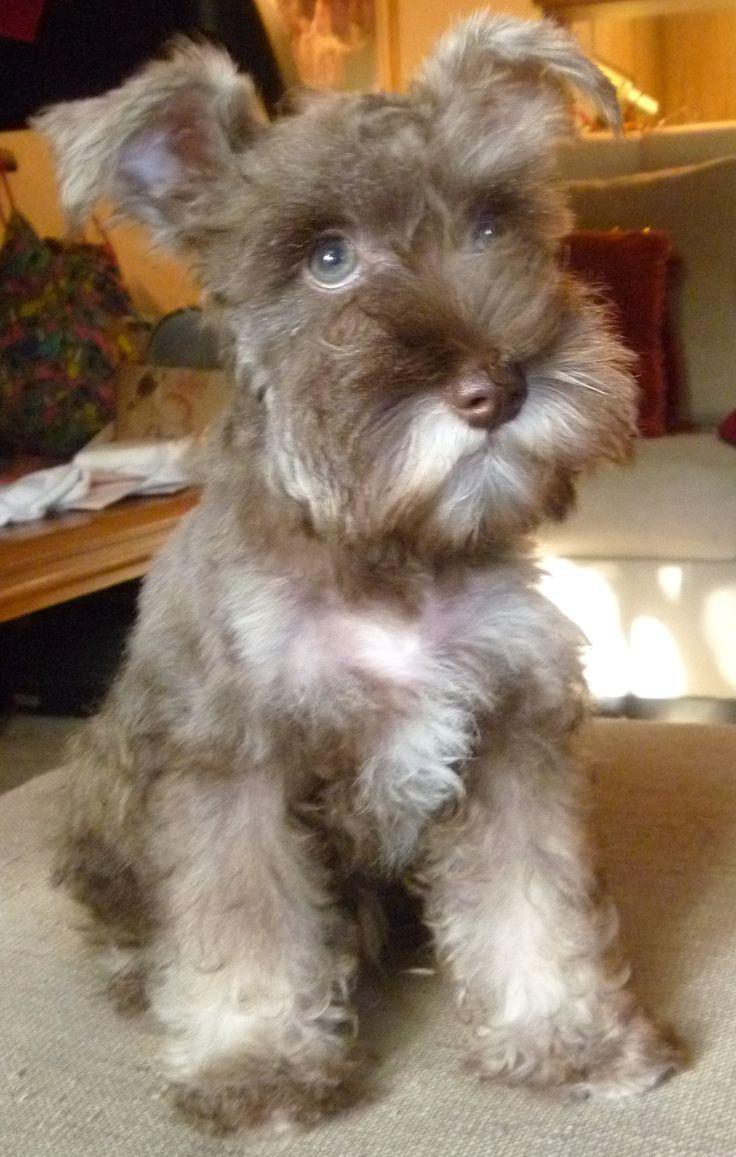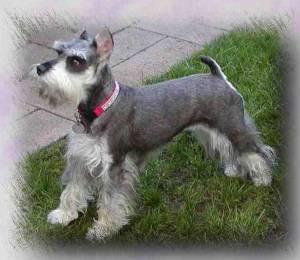The first image is the image on the left, the second image is the image on the right. Assess this claim about the two images: "Only one little dog is wearing a collar.". Correct or not? Answer yes or no. Yes. The first image is the image on the left, the second image is the image on the right. Analyze the images presented: Is the assertion "Both dogs are standing on the grass." valid? Answer yes or no. No. The first image is the image on the left, the second image is the image on the right. Evaluate the accuracy of this statement regarding the images: "Both images contain exactly one dog that is standing on grass.". Is it true? Answer yes or no. No. The first image is the image on the left, the second image is the image on the right. For the images shown, is this caption "One dog has a red collar." true? Answer yes or no. Yes. 